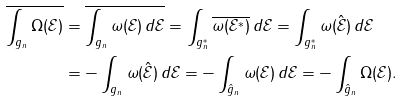<formula> <loc_0><loc_0><loc_500><loc_500>\overline { \int _ { g _ { n } } \Omega ( { \mathcal { E } } ) } & = \overline { \int _ { g _ { n } } \omega ( { \mathcal { E } } ) \, d { \mathcal { E } } } = \int _ { g _ { n } ^ { * } } \overline { \omega ( { \mathcal { E } } ^ { * } ) } \, d { \mathcal { E } } = \int _ { g _ { n } ^ { * } } \omega ( \hat { \mathcal { E } } ) \, d { \mathcal { E } } \\ & = - \int _ { g _ { n } } \omega ( \hat { \mathcal { E } } ) \, d { \mathcal { E } } = - \int _ { \hat { g } _ { n } } \omega ( { \mathcal { E } } ) \, d { \mathcal { E } } = - \int _ { \hat { g } _ { n } } \Omega ( { \mathcal { E } } ) .</formula> 